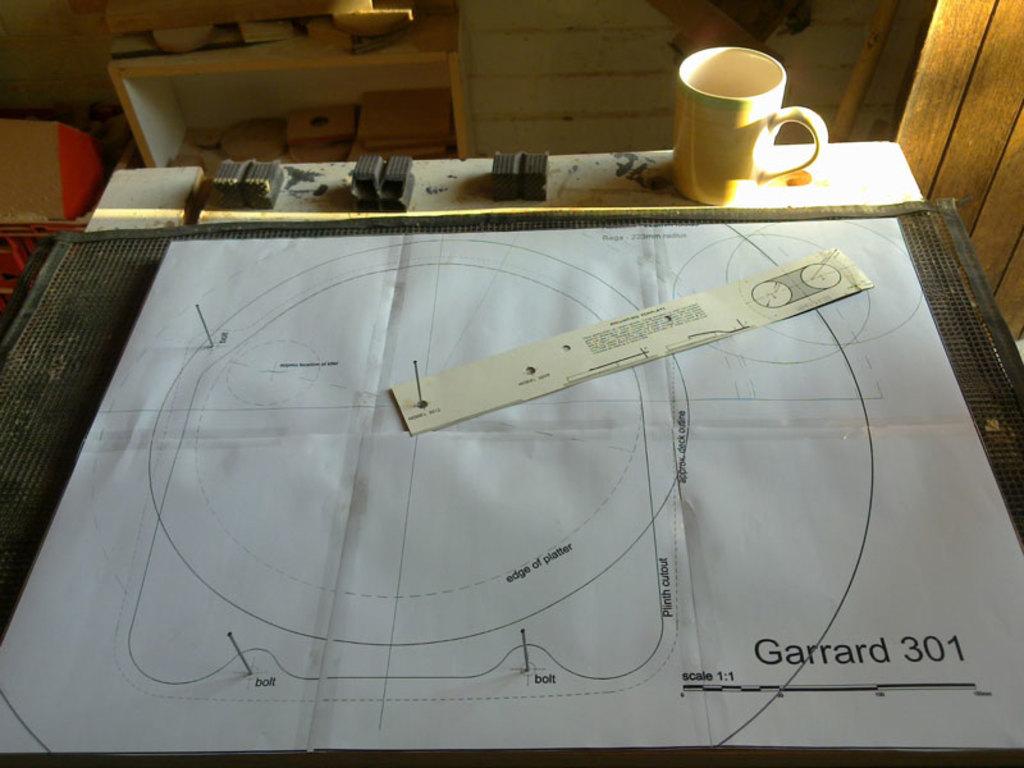What word is before 301?
Give a very brief answer. Garrard. What is the number on the bottom right?
Ensure brevity in your answer.  301. 